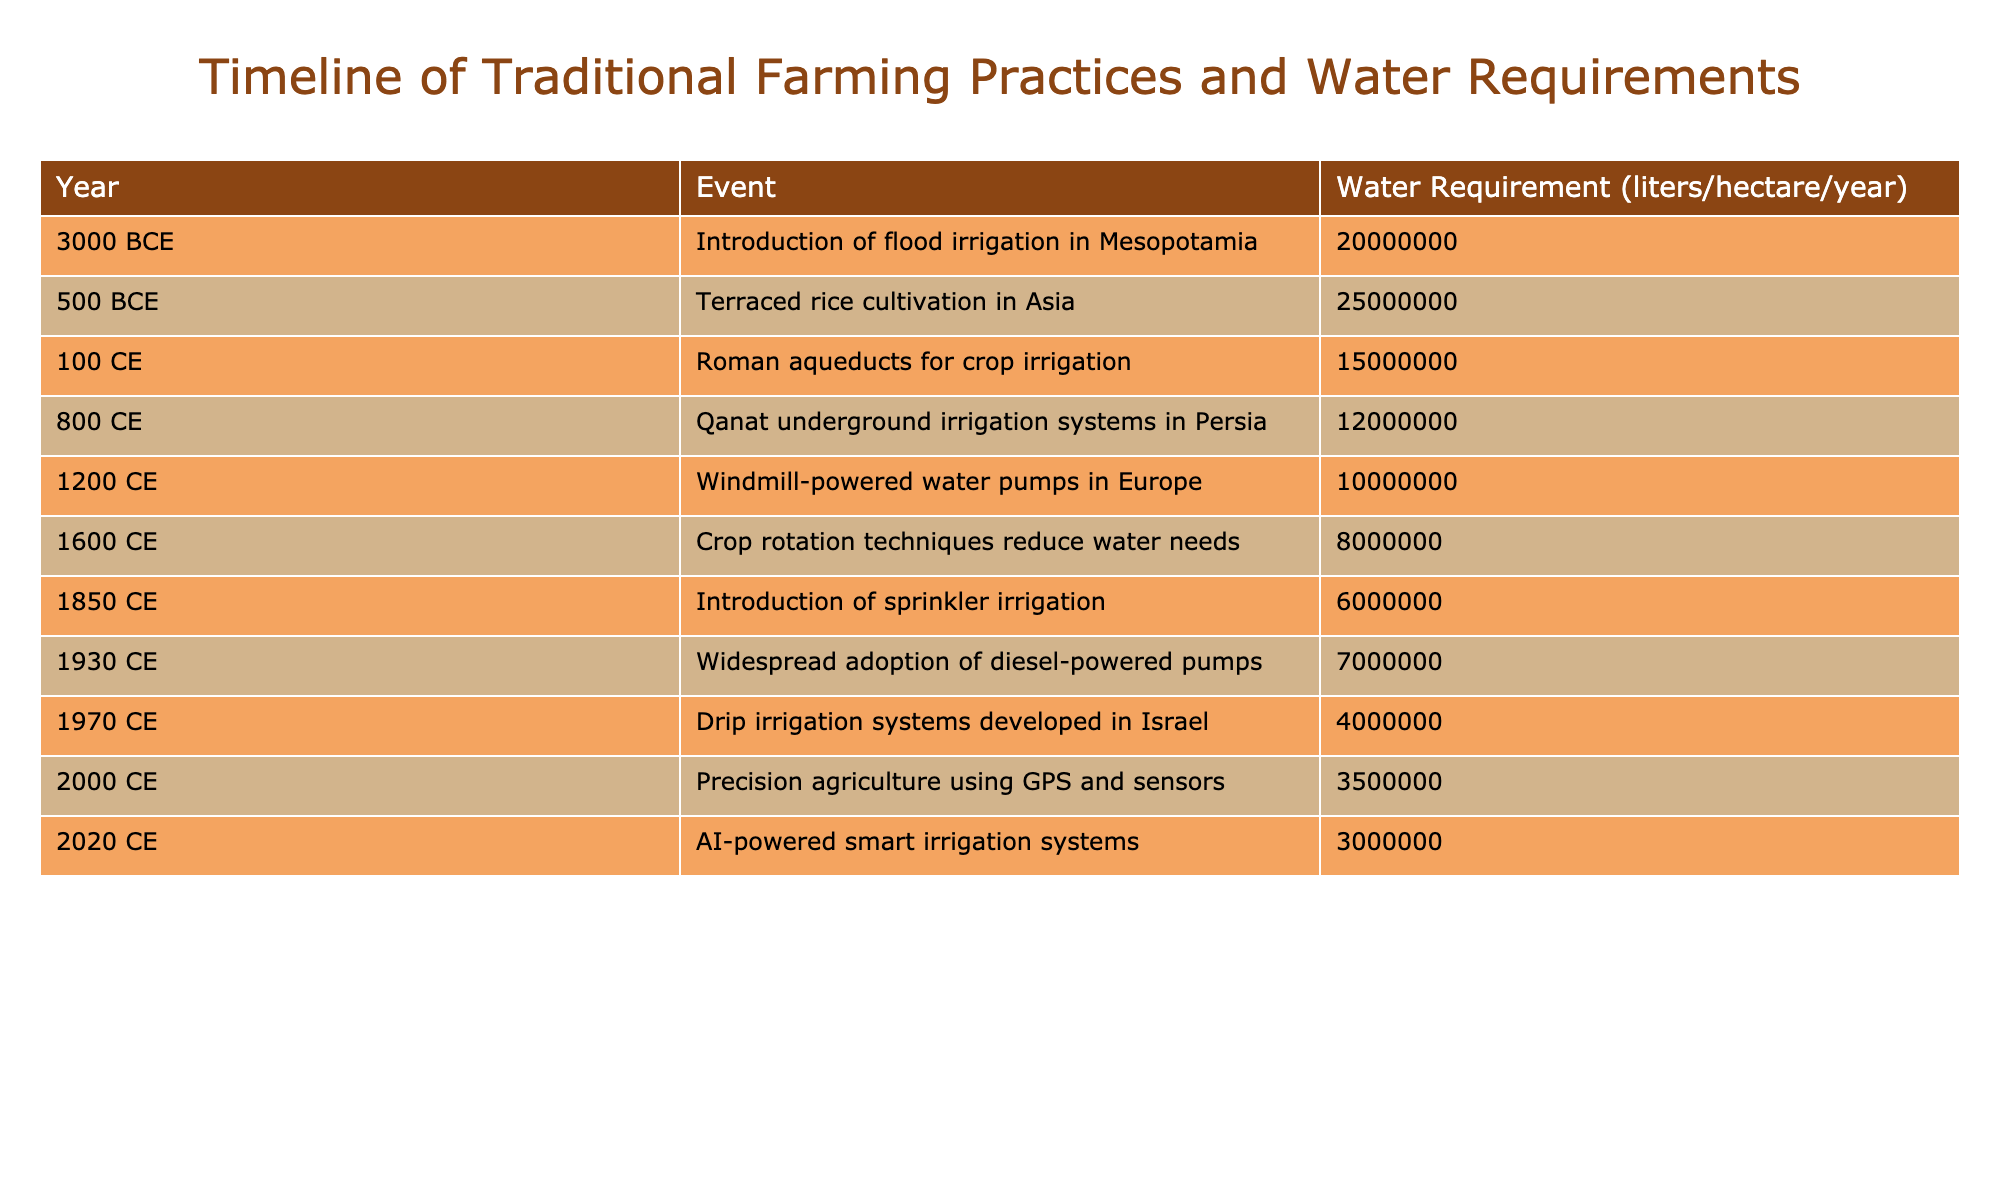What year did the introduction of flood irrigation in Mesopotamia occur? The table lists the event "Introduction of flood irrigation in Mesopotamia" under the year column, showing it took place in 3000 BCE
Answer: 3000 BCE What is the water requirement for drip irrigation systems developed in Israel? From the table, the water requirement for "Drip irrigation systems developed in Israel" is listed as 4000000 liters/hectare/year
Answer: 4000000 liters/hectare/year Which irrigation system had the lowest annual water requirement and what was its value? The table indicates that "AI-powered smart irrigation systems" in 2020 required only 3000000 liters/hectare/year, making it the lowest in the list
Answer: 3000000 liters/hectare/year Is the water requirement for terraced rice cultivation higher than that of crop rotation techniques? The water requirement for "Terraced rice cultivation in Asia" is 25000000 liters/hectare/year while that for "Crop rotation techniques" is 8000000 liters/hectare/year. Since 25000000 is greater than 8000000, the statement is true
Answer: Yes What is the average water requirement of the irrigation systems introduced before the year 1000 CE? To find the average, first add the water requirements of the events prior to 1000 CE: 20000000 (flood irrigation) + 25000000 (terraced rice cultivation) + 15000000 (Roman aqueducts) + 12000000 (Qanat systems) + 10000000 (windmill pumps) which equals 92000000. Then divide by 5 (the number of events) which gives an average of 18400000 liters/hectare/year
Answer: 18400000 liters/hectare/year Which farming practice introduced in the 19th century required less water than the introduction of diesel-powered pumps? The table shows "Introduction of sprinkler irrigation" in 1850 CE with a requirement of 6000000 liters/hectare/year and "Widespread adoption of diesel-powered pumps" in 1930 CE requiring 7000000 liters/hectare/year. Thus, sprinkler irrigation required less water
Answer: Yes 